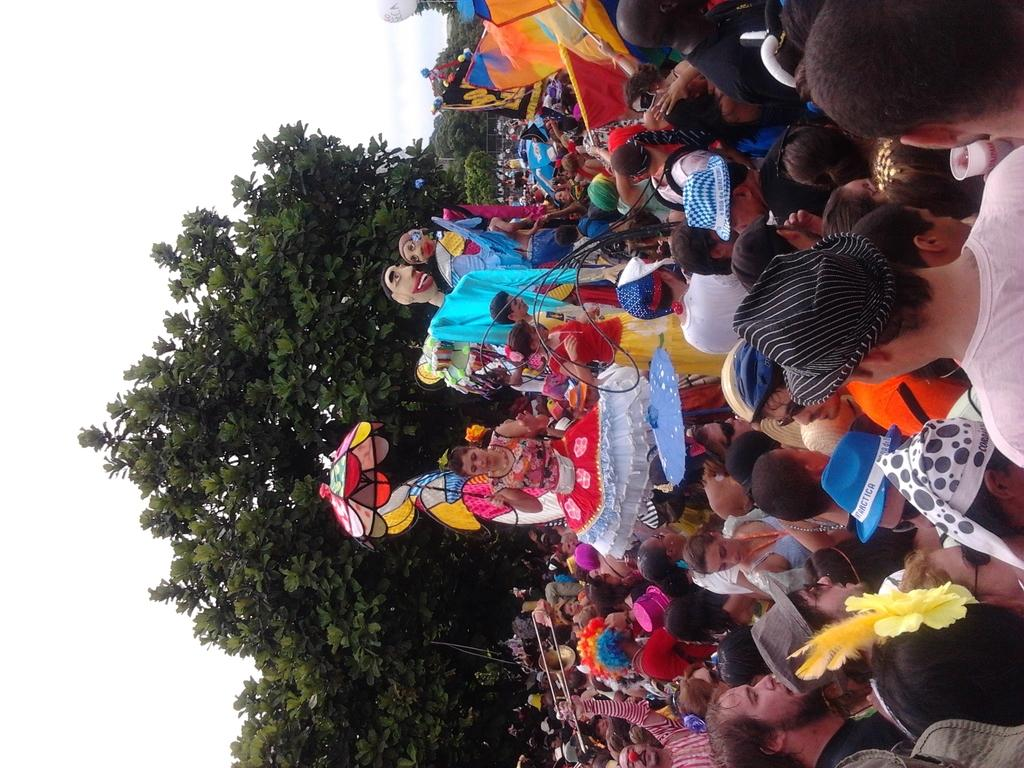What are the people in the image doing? The people in the image are standing on the road. Can you describe the appearance of some of the people in the image? Some of the people are wearing costumes. What can be seen in the background of the image? There are trees and the sky visible in the background of the image. What type of winter sport is being played in the image? There is no winter sport or any indication of winter in the image; it features people standing on the road, some of whom are wearing costumes. How does the zephyr affect the people in the image? There is no mention of a zephyr or any wind in the image; it simply shows people standing on the road. 